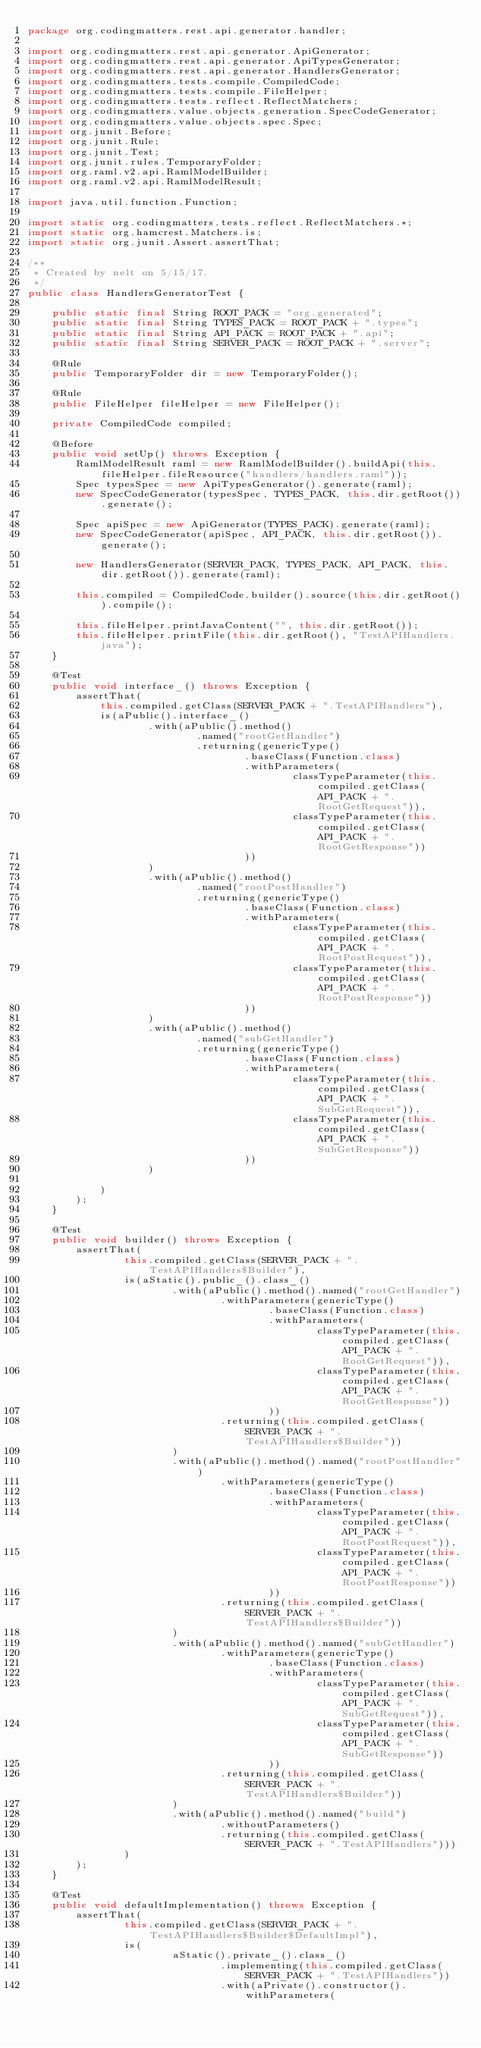<code> <loc_0><loc_0><loc_500><loc_500><_Java_>package org.codingmatters.rest.api.generator.handler;

import org.codingmatters.rest.api.generator.ApiGenerator;
import org.codingmatters.rest.api.generator.ApiTypesGenerator;
import org.codingmatters.rest.api.generator.HandlersGenerator;
import org.codingmatters.tests.compile.CompiledCode;
import org.codingmatters.tests.compile.FileHelper;
import org.codingmatters.tests.reflect.ReflectMatchers;
import org.codingmatters.value.objects.generation.SpecCodeGenerator;
import org.codingmatters.value.objects.spec.Spec;
import org.junit.Before;
import org.junit.Rule;
import org.junit.Test;
import org.junit.rules.TemporaryFolder;
import org.raml.v2.api.RamlModelBuilder;
import org.raml.v2.api.RamlModelResult;

import java.util.function.Function;

import static org.codingmatters.tests.reflect.ReflectMatchers.*;
import static org.hamcrest.Matchers.is;
import static org.junit.Assert.assertThat;

/**
 * Created by nelt on 5/15/17.
 */
public class HandlersGeneratorTest {

    public static final String ROOT_PACK = "org.generated";
    public static final String TYPES_PACK = ROOT_PACK + ".types";
    public static final String API_PACK = ROOT_PACK + ".api";
    public static final String SERVER_PACK = ROOT_PACK + ".server";

    @Rule
    public TemporaryFolder dir = new TemporaryFolder();

    @Rule
    public FileHelper fileHelper = new FileHelper();

    private CompiledCode compiled;

    @Before
    public void setUp() throws Exception {
        RamlModelResult raml = new RamlModelBuilder().buildApi(this.fileHelper.fileResource("handlers/handlers.raml"));
        Spec typesSpec = new ApiTypesGenerator().generate(raml);
        new SpecCodeGenerator(typesSpec, TYPES_PACK, this.dir.getRoot()).generate();

        Spec apiSpec = new ApiGenerator(TYPES_PACK).generate(raml);
        new SpecCodeGenerator(apiSpec, API_PACK, this.dir.getRoot()).generate();

        new HandlersGenerator(SERVER_PACK, TYPES_PACK, API_PACK, this.dir.getRoot()).generate(raml);

        this.compiled = CompiledCode.builder().source(this.dir.getRoot()).compile();

        this.fileHelper.printJavaContent("", this.dir.getRoot());
        this.fileHelper.printFile(this.dir.getRoot(), "TestAPIHandlers.java");
    }

    @Test
    public void interface_() throws Exception {
        assertThat(
            this.compiled.getClass(SERVER_PACK + ".TestAPIHandlers"),
            is(aPublic().interface_()
                    .with(aPublic().method()
                            .named("rootGetHandler")
                            .returning(genericType()
                                    .baseClass(Function.class)
                                    .withParameters(
                                            classTypeParameter(this.compiled.getClass(API_PACK + ".RootGetRequest")),
                                            classTypeParameter(this.compiled.getClass(API_PACK + ".RootGetResponse"))
                                    ))
                    )
                    .with(aPublic().method()
                            .named("rootPostHandler")
                            .returning(genericType()
                                    .baseClass(Function.class)
                                    .withParameters(
                                            classTypeParameter(this.compiled.getClass(API_PACK + ".RootPostRequest")),
                                            classTypeParameter(this.compiled.getClass(API_PACK + ".RootPostResponse"))
                                    ))
                    )
                    .with(aPublic().method()
                            .named("subGetHandler")
                            .returning(genericType()
                                    .baseClass(Function.class)
                                    .withParameters(
                                            classTypeParameter(this.compiled.getClass(API_PACK + ".SubGetRequest")),
                                            classTypeParameter(this.compiled.getClass(API_PACK + ".SubGetResponse"))
                                    ))
                    )

            )
        );
    }

    @Test
    public void builder() throws Exception {
        assertThat(
                this.compiled.getClass(SERVER_PACK + ".TestAPIHandlers$Builder"),
                is(aStatic().public_().class_()
                        .with(aPublic().method().named("rootGetHandler")
                                .withParameters(genericType()
                                        .baseClass(Function.class)
                                        .withParameters(
                                                classTypeParameter(this.compiled.getClass(API_PACK + ".RootGetRequest")),
                                                classTypeParameter(this.compiled.getClass(API_PACK + ".RootGetResponse"))
                                        ))
                                .returning(this.compiled.getClass(SERVER_PACK + ".TestAPIHandlers$Builder"))
                        )
                        .with(aPublic().method().named("rootPostHandler")
                                .withParameters(genericType()
                                        .baseClass(Function.class)
                                        .withParameters(
                                                classTypeParameter(this.compiled.getClass(API_PACK + ".RootPostRequest")),
                                                classTypeParameter(this.compiled.getClass(API_PACK + ".RootPostResponse"))
                                        ))
                                .returning(this.compiled.getClass(SERVER_PACK + ".TestAPIHandlers$Builder"))
                        )
                        .with(aPublic().method().named("subGetHandler")
                                .withParameters(genericType()
                                        .baseClass(Function.class)
                                        .withParameters(
                                                classTypeParameter(this.compiled.getClass(API_PACK + ".SubGetRequest")),
                                                classTypeParameter(this.compiled.getClass(API_PACK + ".SubGetResponse"))
                                        ))
                                .returning(this.compiled.getClass(SERVER_PACK + ".TestAPIHandlers$Builder"))
                        )
                        .with(aPublic().method().named("build")
                                .withoutParameters()
                                .returning(this.compiled.getClass(SERVER_PACK + ".TestAPIHandlers")))
                )
        );
    }

    @Test
    public void defaultImplementation() throws Exception {
        assertThat(
                this.compiled.getClass(SERVER_PACK + ".TestAPIHandlers$Builder$DefaultImpl"),
                is(
                        aStatic().private_().class_()
                                .implementing(this.compiled.getClass(SERVER_PACK + ".TestAPIHandlers"))
                                .with(aPrivate().constructor().withParameters(</code> 